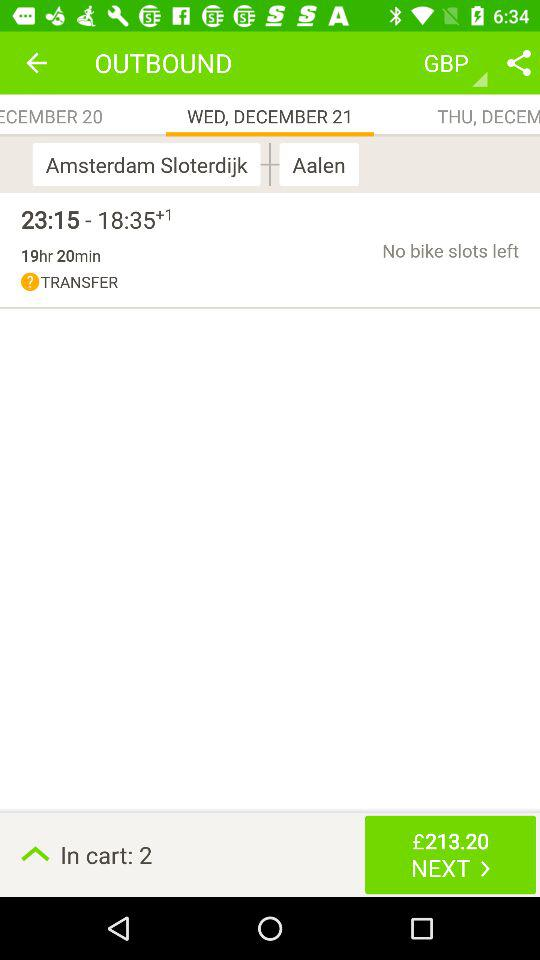What is the time duration? The time duration is 19 hours 20 minutes. 